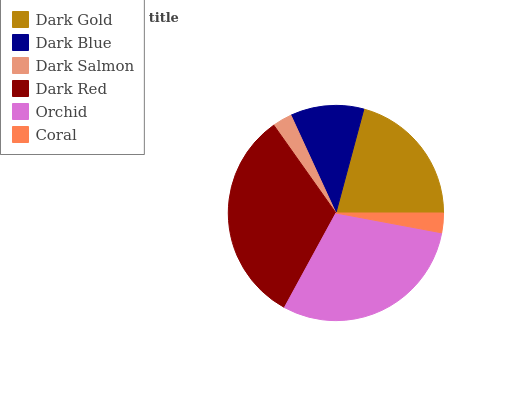Is Dark Salmon the minimum?
Answer yes or no. Yes. Is Dark Red the maximum?
Answer yes or no. Yes. Is Dark Blue the minimum?
Answer yes or no. No. Is Dark Blue the maximum?
Answer yes or no. No. Is Dark Gold greater than Dark Blue?
Answer yes or no. Yes. Is Dark Blue less than Dark Gold?
Answer yes or no. Yes. Is Dark Blue greater than Dark Gold?
Answer yes or no. No. Is Dark Gold less than Dark Blue?
Answer yes or no. No. Is Dark Gold the high median?
Answer yes or no. Yes. Is Dark Blue the low median?
Answer yes or no. Yes. Is Dark Salmon the high median?
Answer yes or no. No. Is Dark Red the low median?
Answer yes or no. No. 